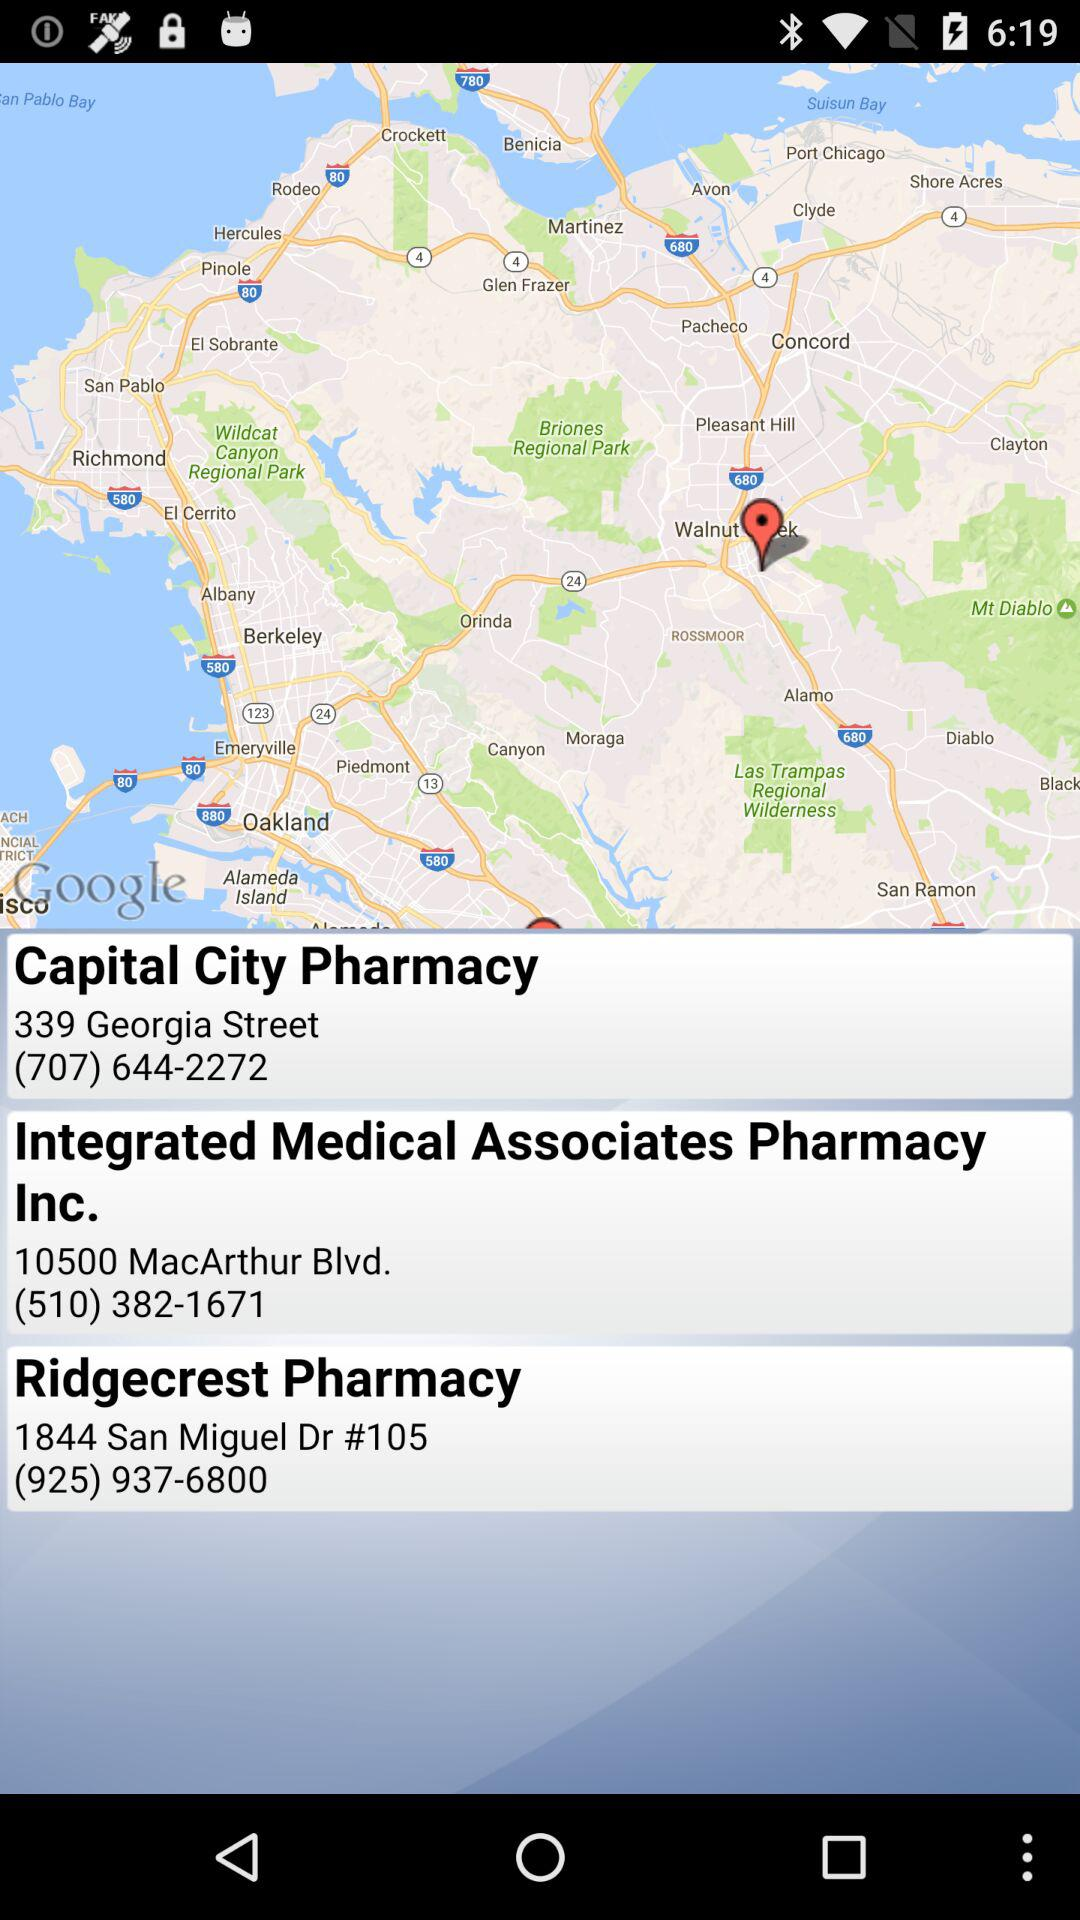What is the contact number for Ridgecrest Pharmacy? The contact number is (925) 937-6800. 